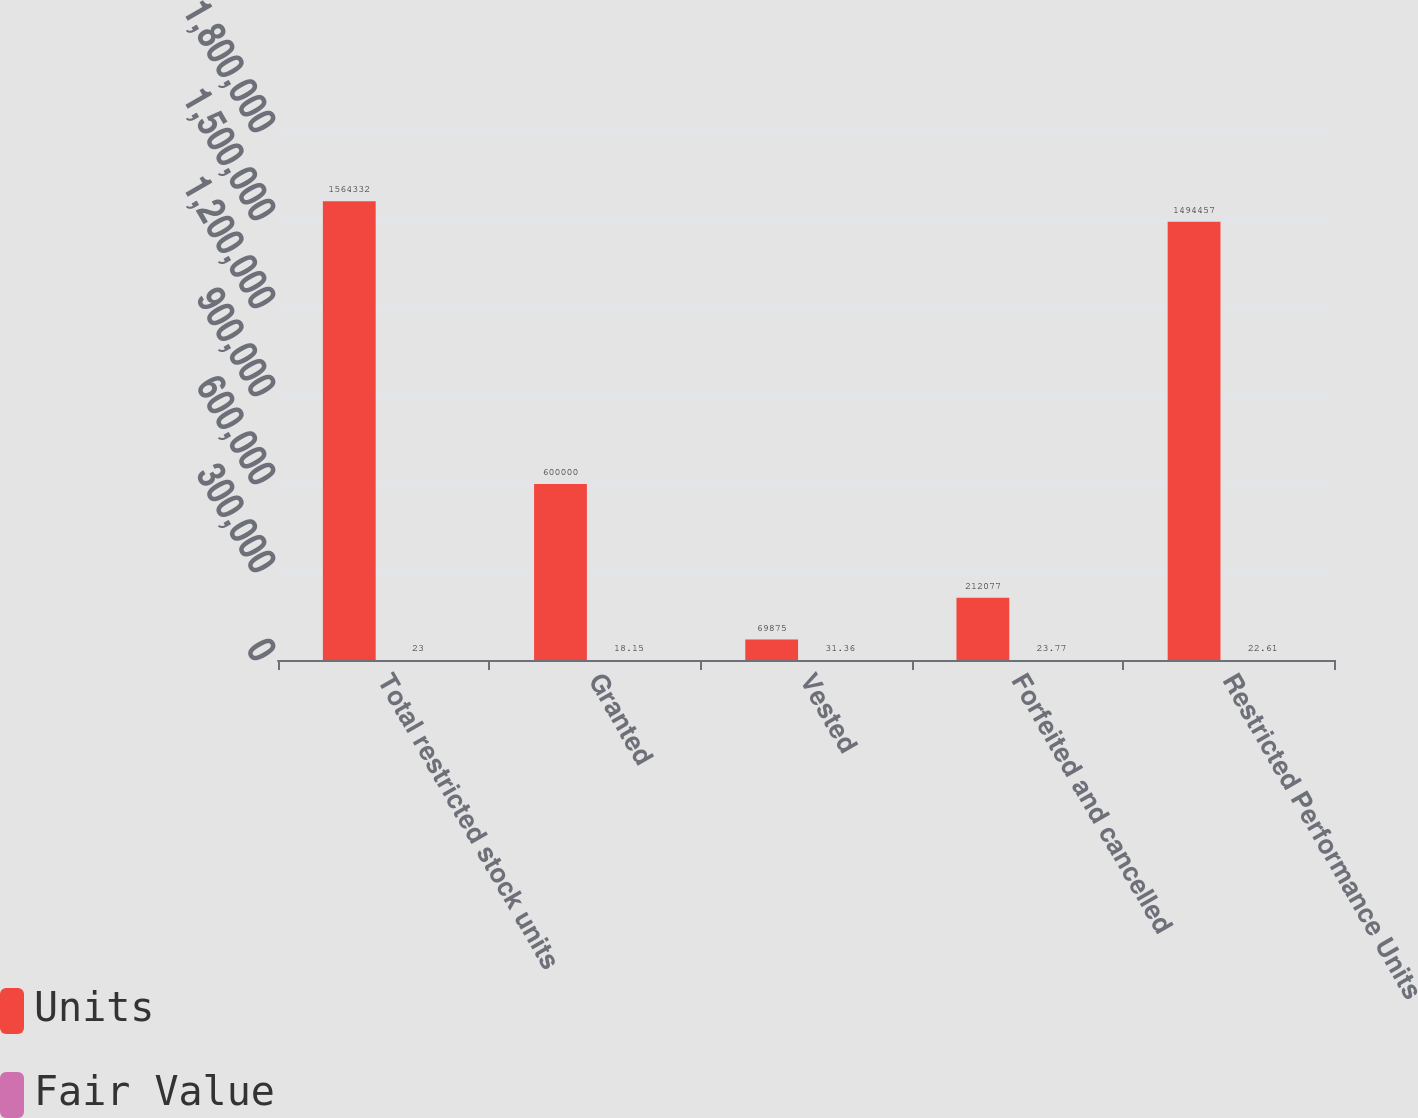Convert chart. <chart><loc_0><loc_0><loc_500><loc_500><stacked_bar_chart><ecel><fcel>Total restricted stock units<fcel>Granted<fcel>Vested<fcel>Forfeited and cancelled<fcel>Restricted Performance Units<nl><fcel>Units<fcel>1.56433e+06<fcel>600000<fcel>69875<fcel>212077<fcel>1.49446e+06<nl><fcel>Fair Value<fcel>23<fcel>18.15<fcel>31.36<fcel>23.77<fcel>22.61<nl></chart> 